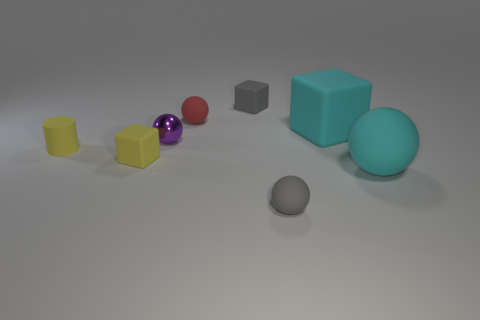Add 1 tiny things. How many objects exist? 9 Subtract all cylinders. How many objects are left? 7 Subtract 0 green balls. How many objects are left? 8 Subtract all cyan rubber cubes. Subtract all shiny objects. How many objects are left? 6 Add 8 red rubber things. How many red rubber things are left? 9 Add 6 large red balls. How many large red balls exist? 6 